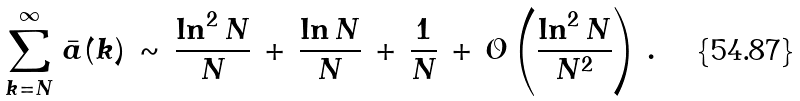<formula> <loc_0><loc_0><loc_500><loc_500>\sum _ { k = N } ^ { \infty } \, { \bar { a } } ( k ) \, \sim \, \frac { \ln ^ { 2 } N } { N } \, + \, \frac { \ln N } { N } \, + \, \frac { 1 } { N } \, + \, { \mathcal { O } } \left ( \frac { \ln ^ { 2 } N } { N ^ { 2 } } \right ) \, .</formula> 